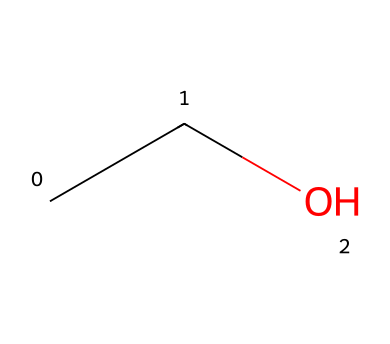What is the chemical name of this compound? The SMILES representation "CCO" corresponds to the compound ethanol, which is a two-carbon alcohol. The "C" represents carbon atoms, and "O" represents an oxygen atom, indicating the presence of a hydroxyl group (-OH) that characterizes alcohols.
Answer: ethanol How many carbon atoms are present in this molecule? By analyzing the SMILES "CCO", there are two "C" symbols, indicating that there are two carbon atoms in the ethanol molecule.
Answer: 2 What type of bond is present between the carbon atoms? In the structure represented by SMILES "CCO", the carbon atoms are connected by a single bond, which is typical for alkyl groups in hydrocarbons, thus no double or triple bonds are present between them.
Answer: single What functional group is present in ethanol? The last part of the SMILES "C" is followed by "O," indicating that there is a hydroxyl group (-OH) attached to the carbon chain, which is a defining feature of alcohols.
Answer: hydroxyl How many hydrogen atoms would be in the complete structure of ethanol? For each carbon atom in ethanol, we can calculate the number of hydrogen atoms. The two carbons will typically bond with enough hydrogens to complete their tetravalency, resulting in a total of six hydrogen atoms for ethanol, according to the formula CnH(2n+1)OH for alcohols.
Answer: 6 Is ethanol a type of hydrocarbon? Ethanol contains carbon and hydrogen atoms; however, due to the presence of the hydroxyl group (alcohol functional group), ethanol is classified specifically as an alcohol rather than a simple hydrocarbon.
Answer: no What is the molecular formula for ethanol? The molecular formula is derived by counting the total numbers of each type of atom in the structure. For ethanol ("CCO"), we observe 2 carbons (C), 6 hydrogens (H), and 1 oxygen (O), which collectively gives us C2H6O.
Answer: C2H6O 